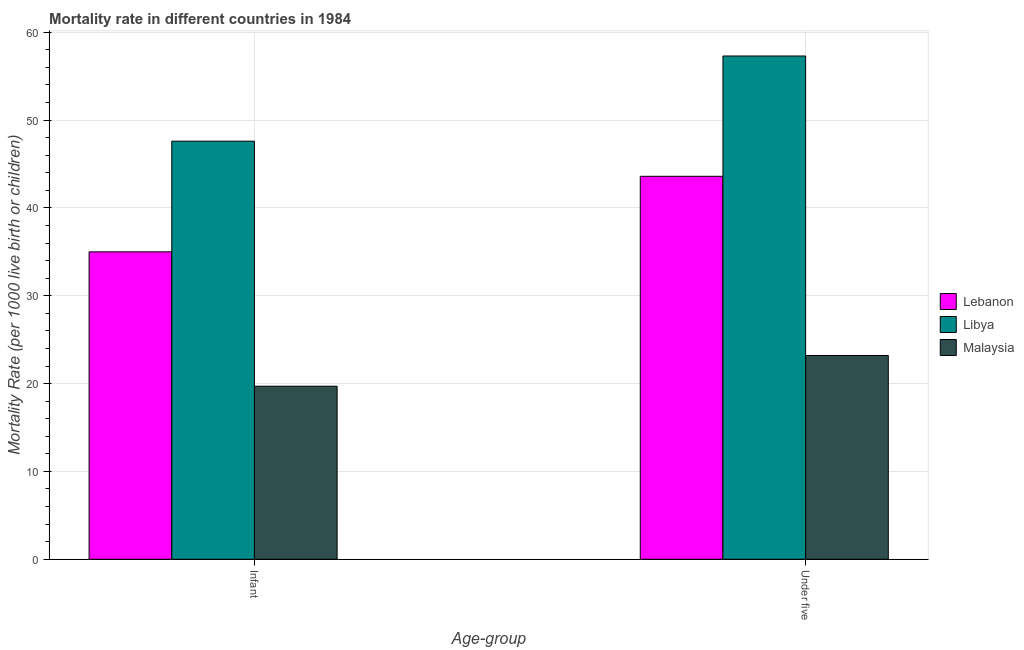How many different coloured bars are there?
Ensure brevity in your answer.  3. How many groups of bars are there?
Give a very brief answer. 2. Are the number of bars on each tick of the X-axis equal?
Ensure brevity in your answer.  Yes. How many bars are there on the 1st tick from the right?
Your response must be concise. 3. What is the label of the 1st group of bars from the left?
Make the answer very short. Infant. What is the infant mortality rate in Malaysia?
Your answer should be very brief. 19.7. Across all countries, what is the maximum under-5 mortality rate?
Make the answer very short. 57.3. Across all countries, what is the minimum under-5 mortality rate?
Ensure brevity in your answer.  23.2. In which country was the under-5 mortality rate maximum?
Your answer should be very brief. Libya. In which country was the under-5 mortality rate minimum?
Keep it short and to the point. Malaysia. What is the total under-5 mortality rate in the graph?
Provide a short and direct response. 124.1. What is the difference between the infant mortality rate in Lebanon and that in Malaysia?
Give a very brief answer. 15.3. What is the average infant mortality rate per country?
Give a very brief answer. 34.1. What is the ratio of the infant mortality rate in Libya to that in Lebanon?
Offer a terse response. 1.36. What does the 1st bar from the left in Under five represents?
Make the answer very short. Lebanon. What does the 1st bar from the right in Under five represents?
Offer a terse response. Malaysia. How many bars are there?
Your answer should be compact. 6. Are all the bars in the graph horizontal?
Provide a short and direct response. No. What is the difference between two consecutive major ticks on the Y-axis?
Give a very brief answer. 10. Are the values on the major ticks of Y-axis written in scientific E-notation?
Make the answer very short. No. Does the graph contain any zero values?
Provide a succinct answer. No. How many legend labels are there?
Ensure brevity in your answer.  3. How are the legend labels stacked?
Keep it short and to the point. Vertical. What is the title of the graph?
Give a very brief answer. Mortality rate in different countries in 1984. What is the label or title of the X-axis?
Offer a terse response. Age-group. What is the label or title of the Y-axis?
Keep it short and to the point. Mortality Rate (per 1000 live birth or children). What is the Mortality Rate (per 1000 live birth or children) of Libya in Infant?
Your response must be concise. 47.6. What is the Mortality Rate (per 1000 live birth or children) in Lebanon in Under five?
Offer a terse response. 43.6. What is the Mortality Rate (per 1000 live birth or children) of Libya in Under five?
Your answer should be very brief. 57.3. What is the Mortality Rate (per 1000 live birth or children) of Malaysia in Under five?
Your answer should be compact. 23.2. Across all Age-group, what is the maximum Mortality Rate (per 1000 live birth or children) of Lebanon?
Offer a terse response. 43.6. Across all Age-group, what is the maximum Mortality Rate (per 1000 live birth or children) in Libya?
Provide a short and direct response. 57.3. Across all Age-group, what is the maximum Mortality Rate (per 1000 live birth or children) of Malaysia?
Give a very brief answer. 23.2. Across all Age-group, what is the minimum Mortality Rate (per 1000 live birth or children) in Libya?
Your answer should be compact. 47.6. Across all Age-group, what is the minimum Mortality Rate (per 1000 live birth or children) in Malaysia?
Provide a short and direct response. 19.7. What is the total Mortality Rate (per 1000 live birth or children) of Lebanon in the graph?
Make the answer very short. 78.6. What is the total Mortality Rate (per 1000 live birth or children) in Libya in the graph?
Keep it short and to the point. 104.9. What is the total Mortality Rate (per 1000 live birth or children) of Malaysia in the graph?
Make the answer very short. 42.9. What is the difference between the Mortality Rate (per 1000 live birth or children) in Libya in Infant and that in Under five?
Offer a very short reply. -9.7. What is the difference between the Mortality Rate (per 1000 live birth or children) of Malaysia in Infant and that in Under five?
Your answer should be compact. -3.5. What is the difference between the Mortality Rate (per 1000 live birth or children) in Lebanon in Infant and the Mortality Rate (per 1000 live birth or children) in Libya in Under five?
Offer a terse response. -22.3. What is the difference between the Mortality Rate (per 1000 live birth or children) in Libya in Infant and the Mortality Rate (per 1000 live birth or children) in Malaysia in Under five?
Your answer should be compact. 24.4. What is the average Mortality Rate (per 1000 live birth or children) in Lebanon per Age-group?
Ensure brevity in your answer.  39.3. What is the average Mortality Rate (per 1000 live birth or children) in Libya per Age-group?
Make the answer very short. 52.45. What is the average Mortality Rate (per 1000 live birth or children) in Malaysia per Age-group?
Your answer should be compact. 21.45. What is the difference between the Mortality Rate (per 1000 live birth or children) of Libya and Mortality Rate (per 1000 live birth or children) of Malaysia in Infant?
Give a very brief answer. 27.9. What is the difference between the Mortality Rate (per 1000 live birth or children) in Lebanon and Mortality Rate (per 1000 live birth or children) in Libya in Under five?
Provide a short and direct response. -13.7. What is the difference between the Mortality Rate (per 1000 live birth or children) in Lebanon and Mortality Rate (per 1000 live birth or children) in Malaysia in Under five?
Your answer should be compact. 20.4. What is the difference between the Mortality Rate (per 1000 live birth or children) of Libya and Mortality Rate (per 1000 live birth or children) of Malaysia in Under five?
Keep it short and to the point. 34.1. What is the ratio of the Mortality Rate (per 1000 live birth or children) of Lebanon in Infant to that in Under five?
Give a very brief answer. 0.8. What is the ratio of the Mortality Rate (per 1000 live birth or children) of Libya in Infant to that in Under five?
Your answer should be very brief. 0.83. What is the ratio of the Mortality Rate (per 1000 live birth or children) in Malaysia in Infant to that in Under five?
Your response must be concise. 0.85. What is the difference between the highest and the lowest Mortality Rate (per 1000 live birth or children) of Lebanon?
Your answer should be very brief. 8.6. What is the difference between the highest and the lowest Mortality Rate (per 1000 live birth or children) of Libya?
Ensure brevity in your answer.  9.7. What is the difference between the highest and the lowest Mortality Rate (per 1000 live birth or children) of Malaysia?
Ensure brevity in your answer.  3.5. 